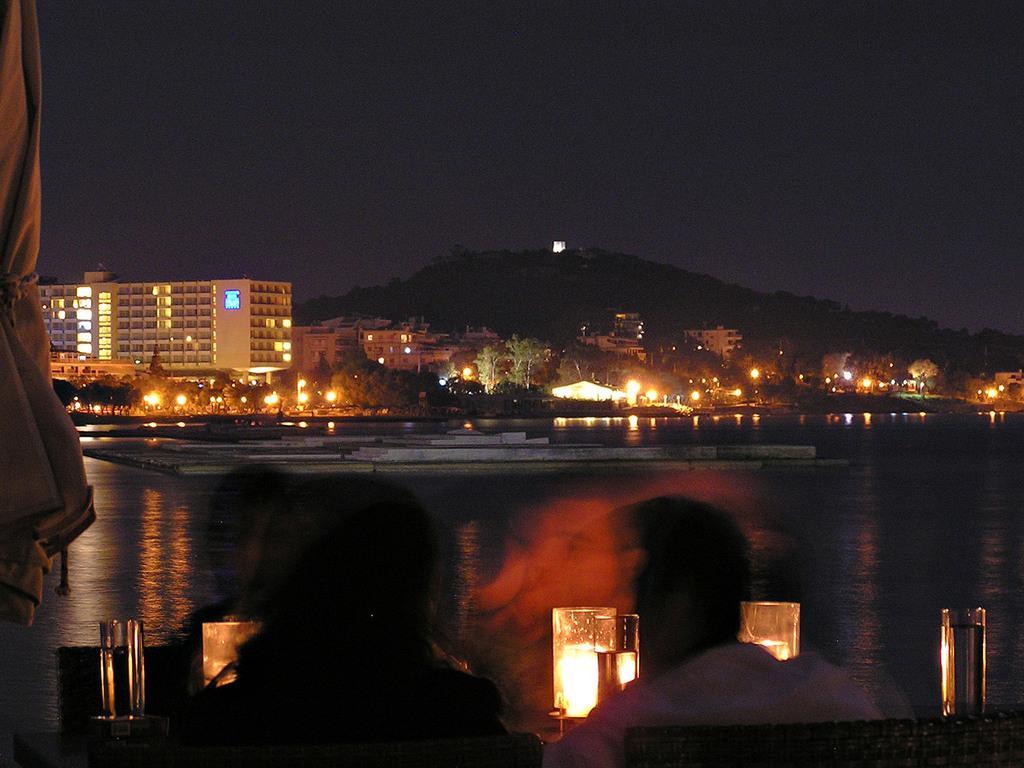Can you describe this image briefly? At the bottom of the image we can see two persons are sitting. On the left side of the image, we can see one cloth. In front of them, we can see the poles, lights and a few other objects. In the background, we can see the sky, hills, buildings, lights, poles, banners, trees, water and a few other objects. 